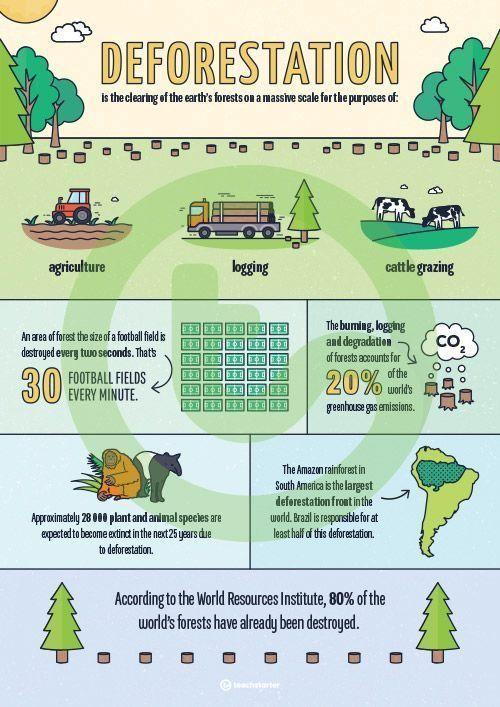List a handful of essential elements in this visual. Deforestation, a significant contributor to climate change and loss of biodiversity, is primarily caused by agriculture, logging, and cattle grazing. These activities result in the clearing of forests for various purposes, leading to the destruction of habitats and the loss of wildlife. 